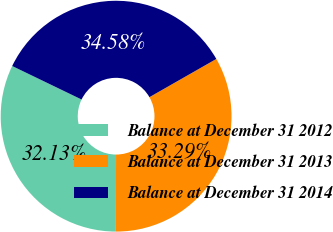Convert chart. <chart><loc_0><loc_0><loc_500><loc_500><pie_chart><fcel>Balance at December 31 2012<fcel>Balance at December 31 2013<fcel>Balance at December 31 2014<nl><fcel>32.13%<fcel>33.29%<fcel>34.58%<nl></chart> 